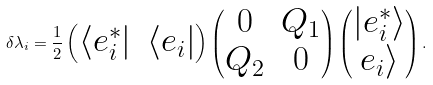<formula> <loc_0><loc_0><loc_500><loc_500>\delta \lambda _ { i } = \frac { 1 } { 2 } \begin{pmatrix} \langle e _ { i } ^ { * } | & \langle e _ { i } | \end{pmatrix} \begin{pmatrix} 0 & Q _ { 1 } \\ Q _ { 2 } & 0 \end{pmatrix} \begin{pmatrix} | e _ { i } ^ { * } \rangle \\ e _ { i } \rangle \end{pmatrix} .</formula> 